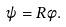<formula> <loc_0><loc_0><loc_500><loc_500>\psi = R \phi .</formula> 